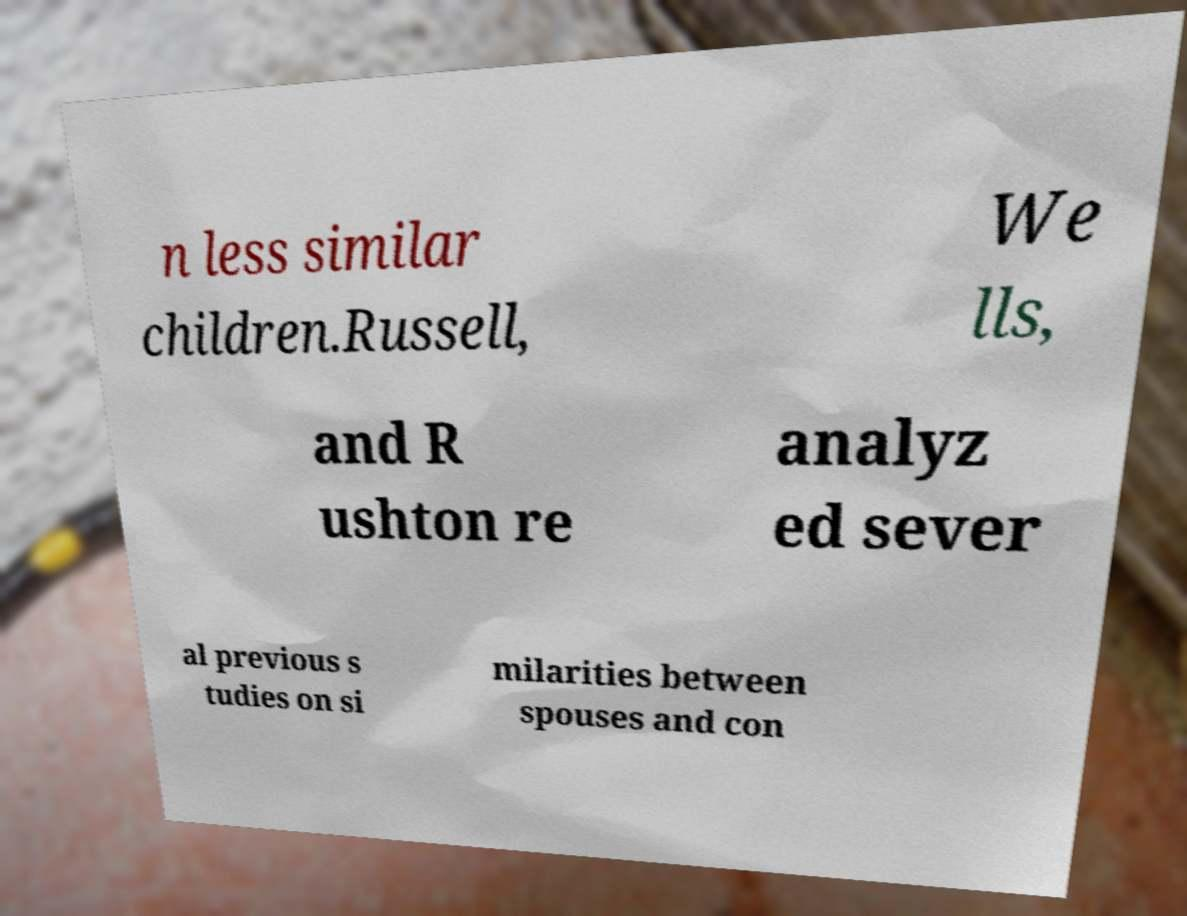Please identify and transcribe the text found in this image. n less similar children.Russell, We lls, and R ushton re analyz ed sever al previous s tudies on si milarities between spouses and con 